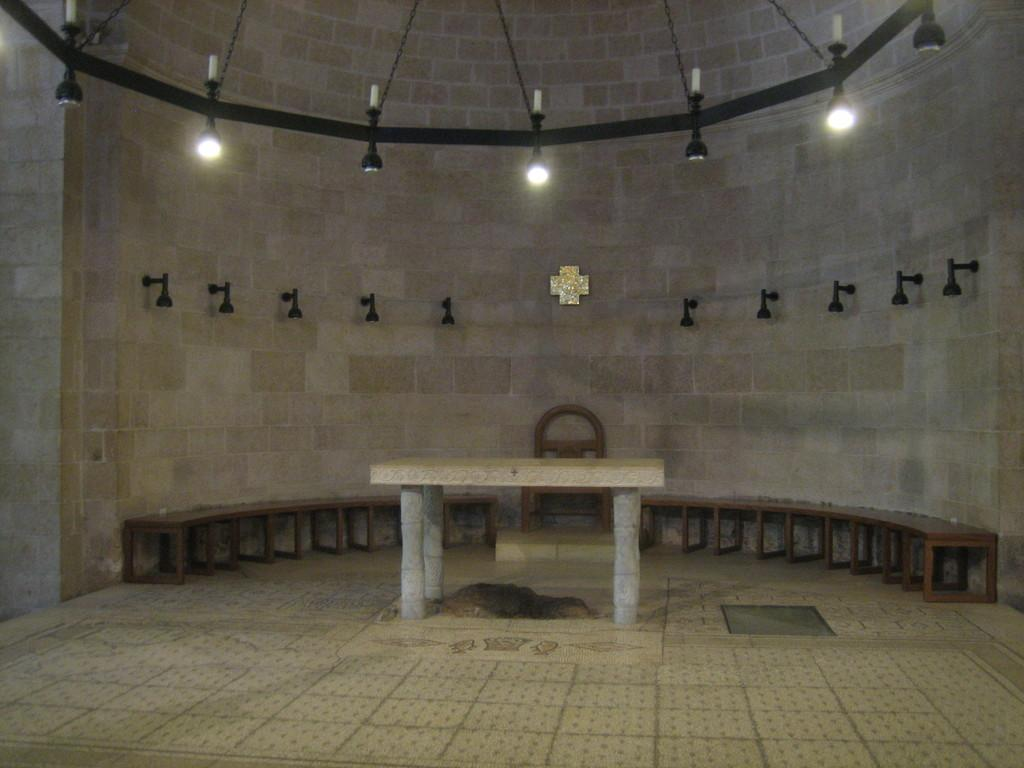What is the main structure in the image? There is a wall in the image. What is placed in front of the wall? There is a table in front of the wall. What type of seating can be seen at the back of the image? There are benches at the back of the image. What type of furniture is present in the image besides the table and benches? There is a chair in the image. What is visible at the top of the image? There are lights visible at the top of the image. Can you tell me how many crimes are being committed in the image? There is no indication of any crime being committed in the image. What color are the eyes of the person in the image? There is no person visible in the image, so it is not possible to determine the color of their eyes. 